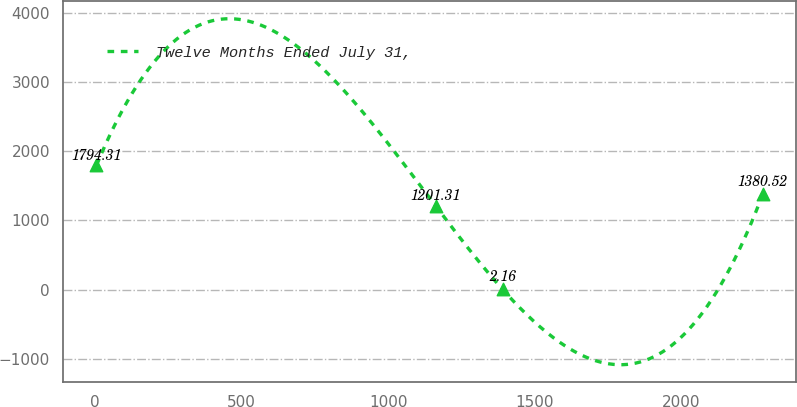Convert chart. <chart><loc_0><loc_0><loc_500><loc_500><line_chart><ecel><fcel>Twelve Months Ended July 31,<nl><fcel>5.86<fcel>1794.31<nl><fcel>1163.13<fcel>1201.31<nl><fcel>1390.28<fcel>2.16<nl><fcel>2277.36<fcel>1380.52<nl></chart> 